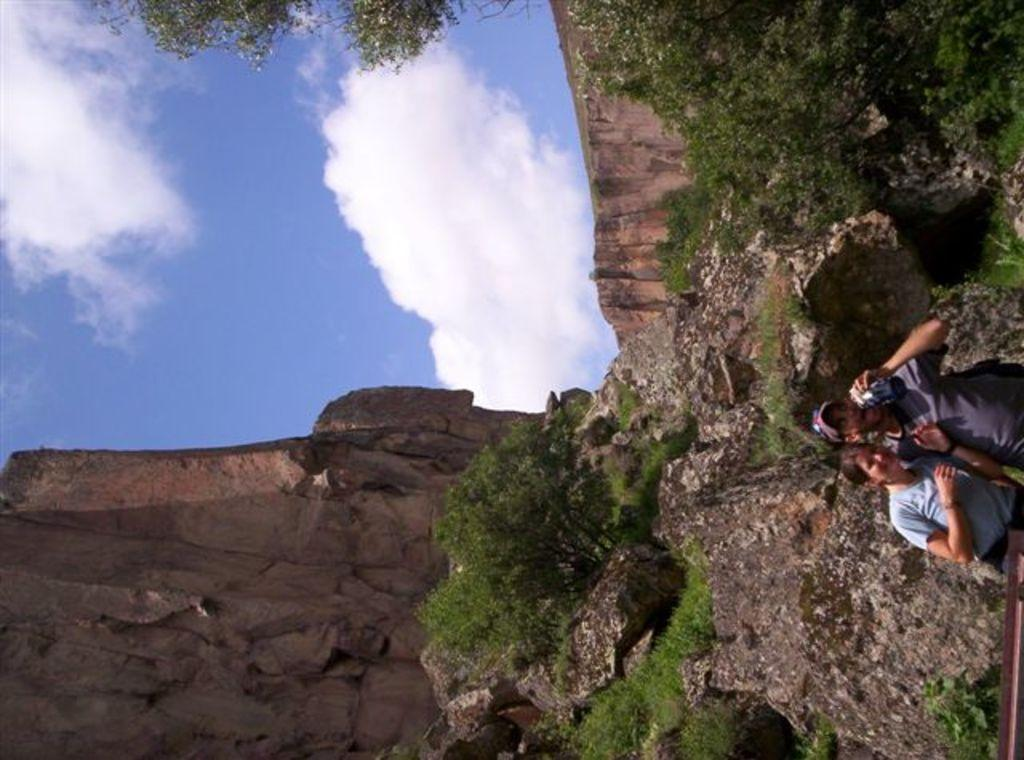How many people are in the image? There are two persons in the image. What type of natural elements can be seen in the image? There are trees and a mountain in the image. What is visible in the sky in the image? Clouds are visible in the sky. What type of friction can be observed between the persons and the trees in the image? There is no friction observed between the persons and the trees in the image, as the image does not depict any interaction between them. 